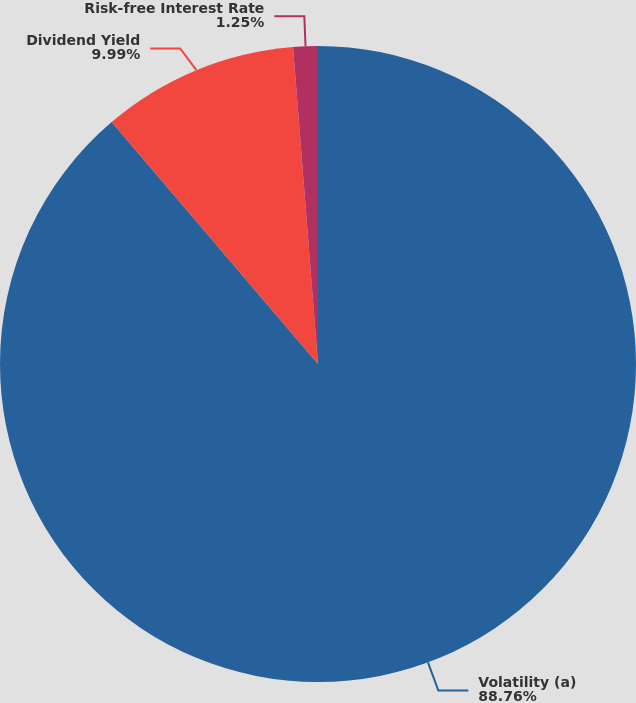<chart> <loc_0><loc_0><loc_500><loc_500><pie_chart><fcel>Volatility (a)<fcel>Dividend Yield<fcel>Risk-free Interest Rate<nl><fcel>88.76%<fcel>9.99%<fcel>1.25%<nl></chart> 